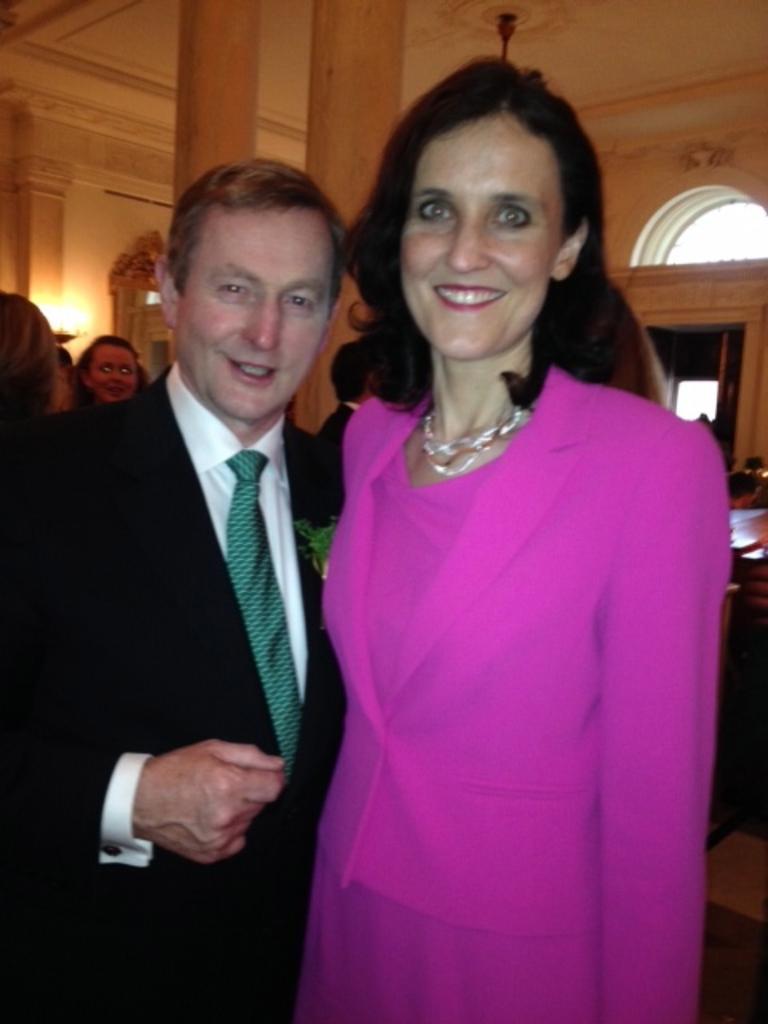How would you summarize this image in a sentence or two? In this image we can see people standing on the floor. In the background there are electric lights and a ceiling fan. 